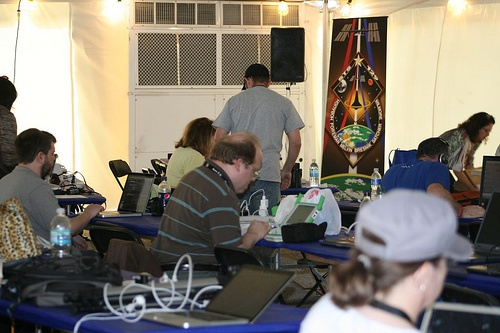Describe the objects in this image and their specific colors. I can see people in tan, darkgray, lightgray, and gray tones, people in tan, black, and gray tones, people in tan, gray, and black tones, people in tan, gray, black, and maroon tones, and laptop in tan, black, and gray tones in this image. 